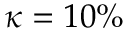<formula> <loc_0><loc_0><loc_500><loc_500>\kappa = 1 0 \%</formula> 